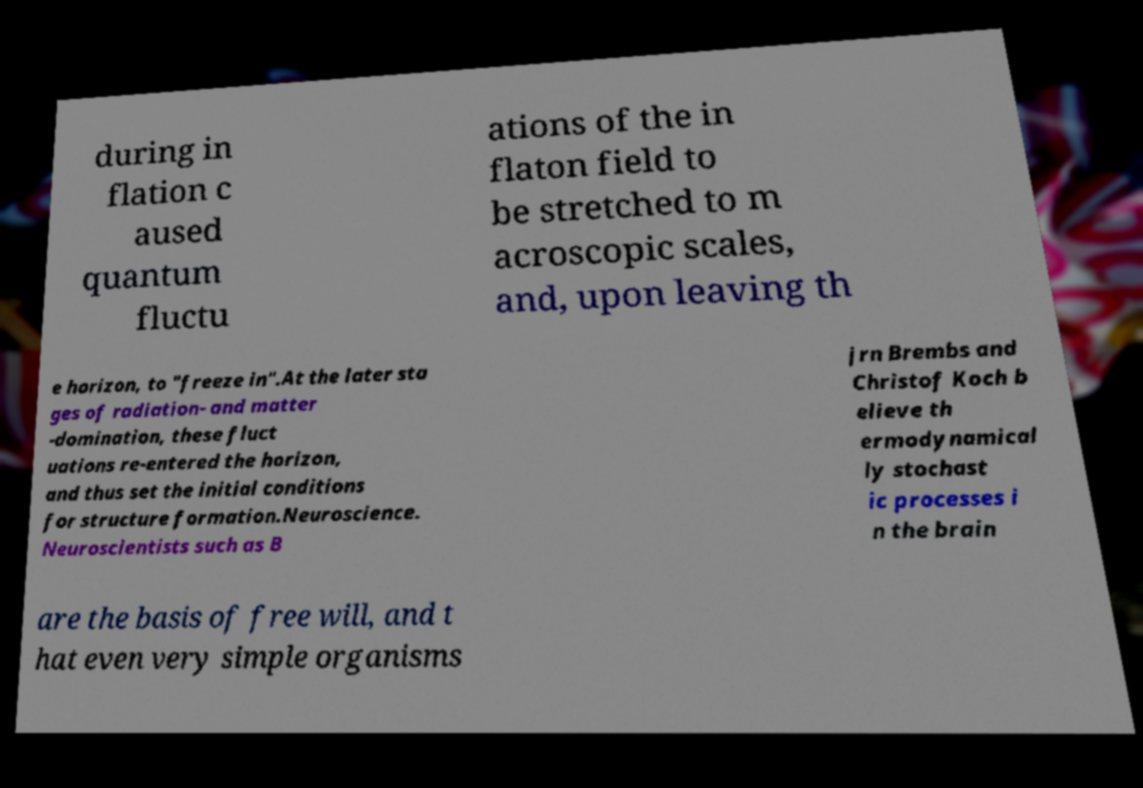Could you assist in decoding the text presented in this image and type it out clearly? during in flation c aused quantum fluctu ations of the in flaton field to be stretched to m acroscopic scales, and, upon leaving th e horizon, to "freeze in".At the later sta ges of radiation- and matter -domination, these fluct uations re-entered the horizon, and thus set the initial conditions for structure formation.Neuroscience. Neuroscientists such as B jrn Brembs and Christof Koch b elieve th ermodynamical ly stochast ic processes i n the brain are the basis of free will, and t hat even very simple organisms 